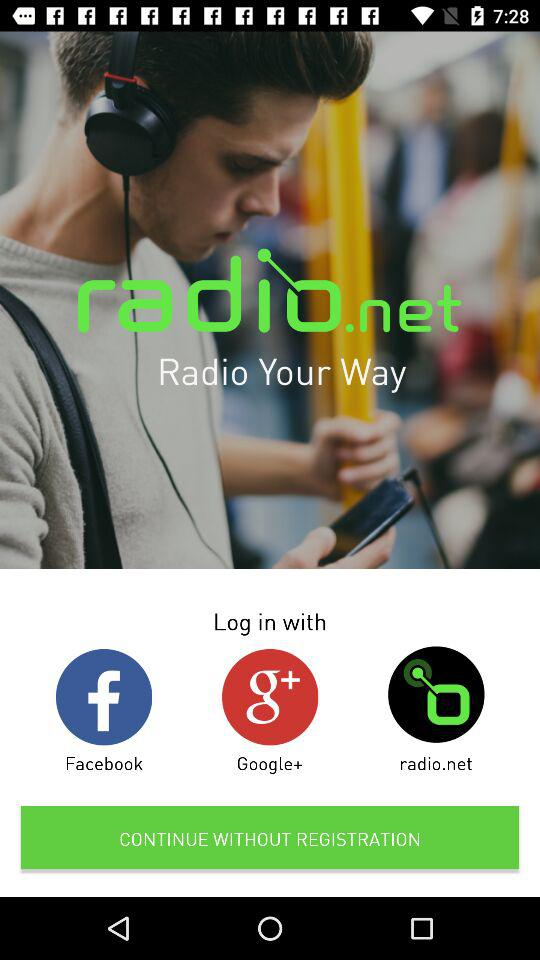What are the login options? The login options are "Facebook", "Google+" and "radio.net". 